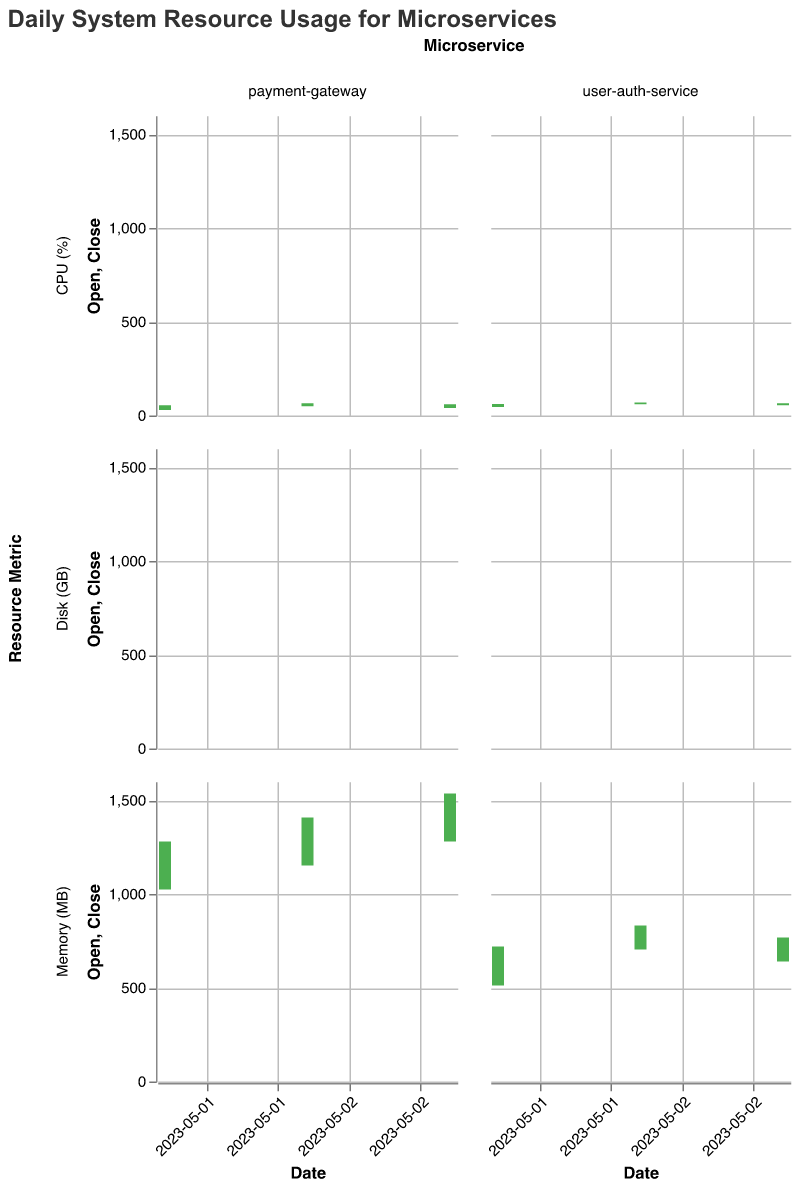What is the title of the chart? The title of the chart is displayed at the top and reads "Daily System Resource Usage for Microservices".
Answer: Daily System Resource Usage for Microservices How many resource metrics are shown for each service? The chart facets the data by "Resource Metric" on rows, showing three metrics for each service: CPU (%), Memory (MB), and Disk (GB).
Answer: 3 Which service had a higher closing CPU usage on 2023-05-02? To determine this, compare the closing CPU usage for both services on 2023-05-02. The user-auth-service closed at 70% while the payment-gateway closed at 65%.
Answer: user-auth-service For the user-auth-service, what is the difference between the highest Memory usage on 2023-05-01 and the highest Memory usage on 2023-05-02? The highest Memory usage for user-auth-service on 2023-05-01 was 768 MB and on 2023-05-02 it was 896 MB. The difference is 896 - 768 = 128 MB.
Answer: 128 MB Did the payment-gateway service's Disk usage improve or degrade from 2023-05-02 to 2023-05-03 based on the closing values? The closing Disk usage for payment-gateway on 2023-05-02 was 4.1 GB, and on 2023-05-03 it was 3.9 GB. Since 4.1 GB is higher than 3.9 GB, Disk usage improved (decreased).
Answer: Improved What was the lowest CPU usage recorded for the payment-gateway service on 2023-05-03? The lowest CPU usage for the payment-gateway service on 2023-05-03 can be found by looking at the "Low" value for that date. It is 30%.
Answer: 30% Compare the closing Memory usage for both services on 2023-05-03. Which one used more memory? On 2023-05-03, the closing Memory usage for user-auth-service was 768 MB and for payment-gateway was 1536 MB. The payment-gateway used more memory.
Answer: payment-gateway For the user-auth-service on 2023-05-02, what was the range of Disk usage? The range of Disk usage is found by subtracting the lowest value from the highest value on that date. For user-auth-service on 2023-05-02: 3.1 GB - 2.2 GB = 0.9 GB.
Answer: 0.9 GB 